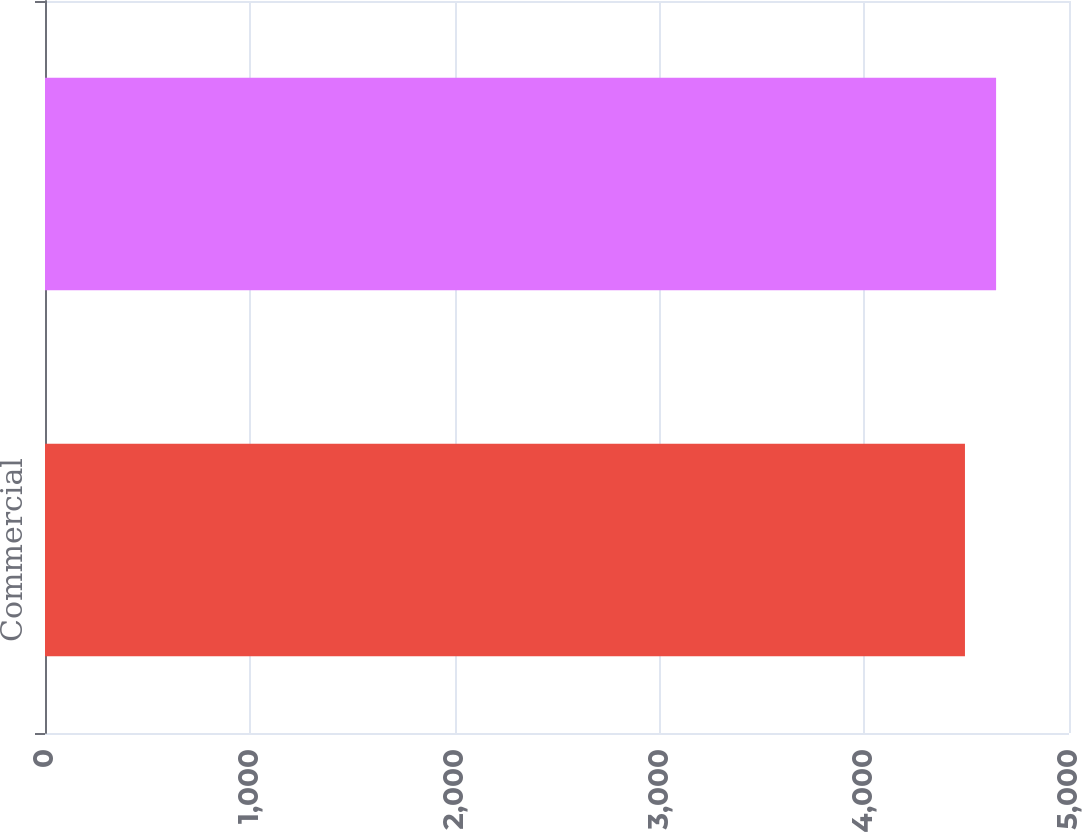Convert chart. <chart><loc_0><loc_0><loc_500><loc_500><bar_chart><fcel>Commercial<fcel>Total mortgage loans<nl><fcel>4492<fcel>4644<nl></chart> 